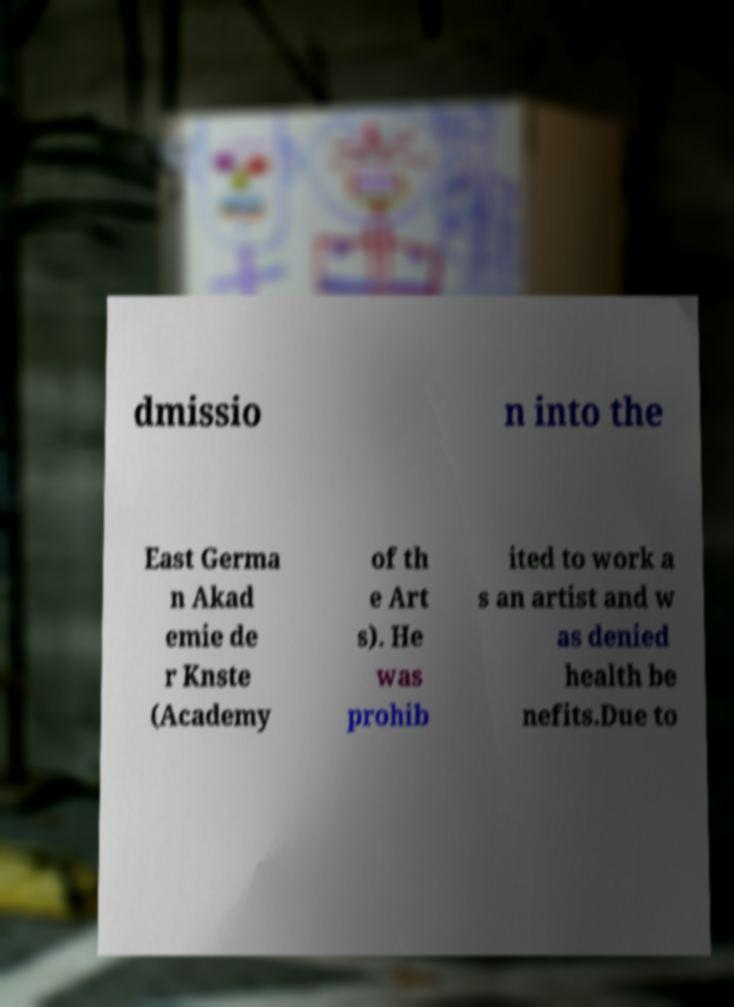What messages or text are displayed in this image? I need them in a readable, typed format. dmissio n into the East Germa n Akad emie de r Knste (Academy of th e Art s). He was prohib ited to work a s an artist and w as denied health be nefits.Due to 